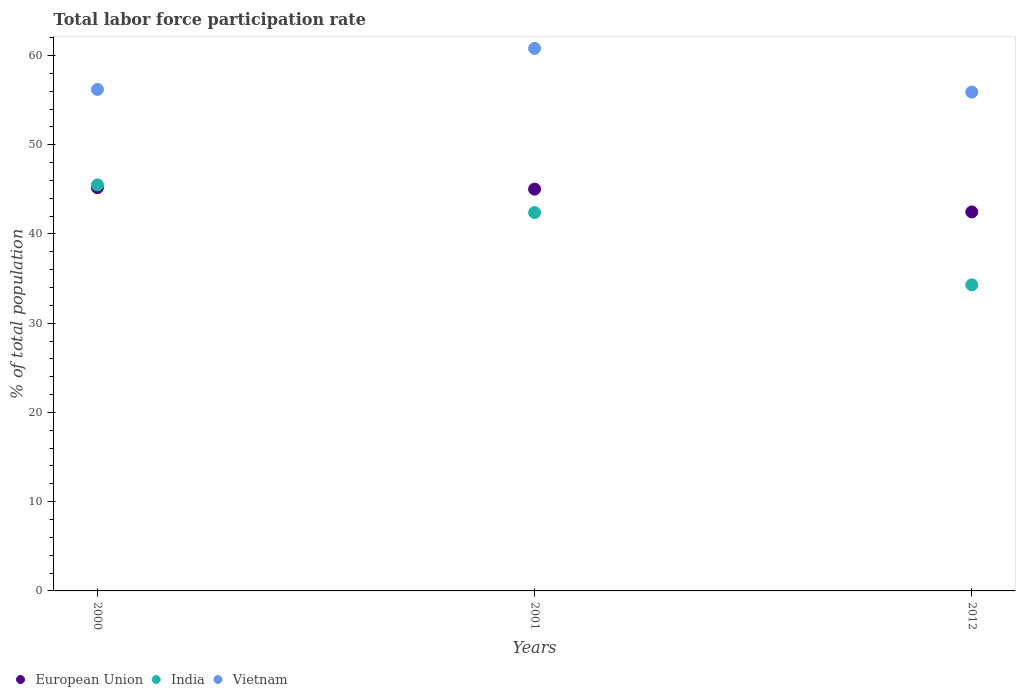Is the number of dotlines equal to the number of legend labels?
Your response must be concise. Yes. What is the total labor force participation rate in India in 2000?
Your answer should be very brief. 45.5. Across all years, what is the maximum total labor force participation rate in India?
Your answer should be very brief. 45.5. Across all years, what is the minimum total labor force participation rate in European Union?
Your response must be concise. 42.47. In which year was the total labor force participation rate in India minimum?
Keep it short and to the point. 2012. What is the total total labor force participation rate in European Union in the graph?
Offer a terse response. 132.69. What is the difference between the total labor force participation rate in Vietnam in 2001 and that in 2012?
Offer a terse response. 4.9. What is the difference between the total labor force participation rate in Vietnam in 2000 and the total labor force participation rate in European Union in 2012?
Ensure brevity in your answer.  13.73. What is the average total labor force participation rate in European Union per year?
Offer a very short reply. 44.23. In the year 2001, what is the difference between the total labor force participation rate in European Union and total labor force participation rate in Vietnam?
Your answer should be compact. -15.77. What is the ratio of the total labor force participation rate in European Union in 2000 to that in 2012?
Your response must be concise. 1.06. What is the difference between the highest and the second highest total labor force participation rate in European Union?
Ensure brevity in your answer.  0.16. What is the difference between the highest and the lowest total labor force participation rate in India?
Your answer should be very brief. 11.2. Is it the case that in every year, the sum of the total labor force participation rate in Vietnam and total labor force participation rate in India  is greater than the total labor force participation rate in European Union?
Provide a short and direct response. Yes. Does the total labor force participation rate in India monotonically increase over the years?
Your response must be concise. No. Is the total labor force participation rate in Vietnam strictly greater than the total labor force participation rate in European Union over the years?
Offer a very short reply. Yes. How many dotlines are there?
Your response must be concise. 3. How many years are there in the graph?
Your response must be concise. 3. Does the graph contain any zero values?
Your answer should be compact. No. Does the graph contain grids?
Provide a short and direct response. No. How are the legend labels stacked?
Your response must be concise. Horizontal. What is the title of the graph?
Ensure brevity in your answer.  Total labor force participation rate. What is the label or title of the X-axis?
Provide a short and direct response. Years. What is the label or title of the Y-axis?
Provide a short and direct response. % of total population. What is the % of total population of European Union in 2000?
Offer a terse response. 45.19. What is the % of total population in India in 2000?
Provide a succinct answer. 45.5. What is the % of total population in Vietnam in 2000?
Your answer should be compact. 56.2. What is the % of total population in European Union in 2001?
Keep it short and to the point. 45.03. What is the % of total population in India in 2001?
Ensure brevity in your answer.  42.4. What is the % of total population of Vietnam in 2001?
Offer a very short reply. 60.8. What is the % of total population of European Union in 2012?
Your response must be concise. 42.47. What is the % of total population of India in 2012?
Your response must be concise. 34.3. What is the % of total population in Vietnam in 2012?
Provide a succinct answer. 55.9. Across all years, what is the maximum % of total population of European Union?
Keep it short and to the point. 45.19. Across all years, what is the maximum % of total population in India?
Keep it short and to the point. 45.5. Across all years, what is the maximum % of total population in Vietnam?
Your answer should be very brief. 60.8. Across all years, what is the minimum % of total population in European Union?
Ensure brevity in your answer.  42.47. Across all years, what is the minimum % of total population of India?
Your answer should be very brief. 34.3. Across all years, what is the minimum % of total population in Vietnam?
Keep it short and to the point. 55.9. What is the total % of total population in European Union in the graph?
Keep it short and to the point. 132.69. What is the total % of total population in India in the graph?
Offer a terse response. 122.2. What is the total % of total population in Vietnam in the graph?
Your answer should be compact. 172.9. What is the difference between the % of total population of European Union in 2000 and that in 2001?
Keep it short and to the point. 0.16. What is the difference between the % of total population of Vietnam in 2000 and that in 2001?
Your response must be concise. -4.6. What is the difference between the % of total population of European Union in 2000 and that in 2012?
Give a very brief answer. 2.72. What is the difference between the % of total population of European Union in 2001 and that in 2012?
Give a very brief answer. 2.56. What is the difference between the % of total population in European Union in 2000 and the % of total population in India in 2001?
Keep it short and to the point. 2.79. What is the difference between the % of total population in European Union in 2000 and the % of total population in Vietnam in 2001?
Give a very brief answer. -15.61. What is the difference between the % of total population of India in 2000 and the % of total population of Vietnam in 2001?
Offer a very short reply. -15.3. What is the difference between the % of total population of European Union in 2000 and the % of total population of India in 2012?
Your answer should be compact. 10.89. What is the difference between the % of total population of European Union in 2000 and the % of total population of Vietnam in 2012?
Ensure brevity in your answer.  -10.71. What is the difference between the % of total population of India in 2000 and the % of total population of Vietnam in 2012?
Provide a short and direct response. -10.4. What is the difference between the % of total population of European Union in 2001 and the % of total population of India in 2012?
Your answer should be compact. 10.73. What is the difference between the % of total population in European Union in 2001 and the % of total population in Vietnam in 2012?
Provide a succinct answer. -10.87. What is the average % of total population in European Union per year?
Ensure brevity in your answer.  44.23. What is the average % of total population in India per year?
Provide a short and direct response. 40.73. What is the average % of total population in Vietnam per year?
Offer a very short reply. 57.63. In the year 2000, what is the difference between the % of total population in European Union and % of total population in India?
Offer a terse response. -0.31. In the year 2000, what is the difference between the % of total population in European Union and % of total population in Vietnam?
Offer a terse response. -11.01. In the year 2000, what is the difference between the % of total population of India and % of total population of Vietnam?
Your response must be concise. -10.7. In the year 2001, what is the difference between the % of total population of European Union and % of total population of India?
Give a very brief answer. 2.63. In the year 2001, what is the difference between the % of total population of European Union and % of total population of Vietnam?
Give a very brief answer. -15.77. In the year 2001, what is the difference between the % of total population of India and % of total population of Vietnam?
Your answer should be compact. -18.4. In the year 2012, what is the difference between the % of total population in European Union and % of total population in India?
Offer a very short reply. 8.17. In the year 2012, what is the difference between the % of total population of European Union and % of total population of Vietnam?
Ensure brevity in your answer.  -13.43. In the year 2012, what is the difference between the % of total population of India and % of total population of Vietnam?
Your answer should be compact. -21.6. What is the ratio of the % of total population of India in 2000 to that in 2001?
Ensure brevity in your answer.  1.07. What is the ratio of the % of total population in Vietnam in 2000 to that in 2001?
Offer a very short reply. 0.92. What is the ratio of the % of total population in European Union in 2000 to that in 2012?
Offer a terse response. 1.06. What is the ratio of the % of total population of India in 2000 to that in 2012?
Offer a terse response. 1.33. What is the ratio of the % of total population of Vietnam in 2000 to that in 2012?
Your response must be concise. 1.01. What is the ratio of the % of total population of European Union in 2001 to that in 2012?
Offer a terse response. 1.06. What is the ratio of the % of total population in India in 2001 to that in 2012?
Make the answer very short. 1.24. What is the ratio of the % of total population of Vietnam in 2001 to that in 2012?
Make the answer very short. 1.09. What is the difference between the highest and the second highest % of total population in European Union?
Make the answer very short. 0.16. What is the difference between the highest and the second highest % of total population of India?
Offer a terse response. 3.1. What is the difference between the highest and the lowest % of total population in European Union?
Provide a short and direct response. 2.72. What is the difference between the highest and the lowest % of total population of India?
Ensure brevity in your answer.  11.2. What is the difference between the highest and the lowest % of total population in Vietnam?
Keep it short and to the point. 4.9. 